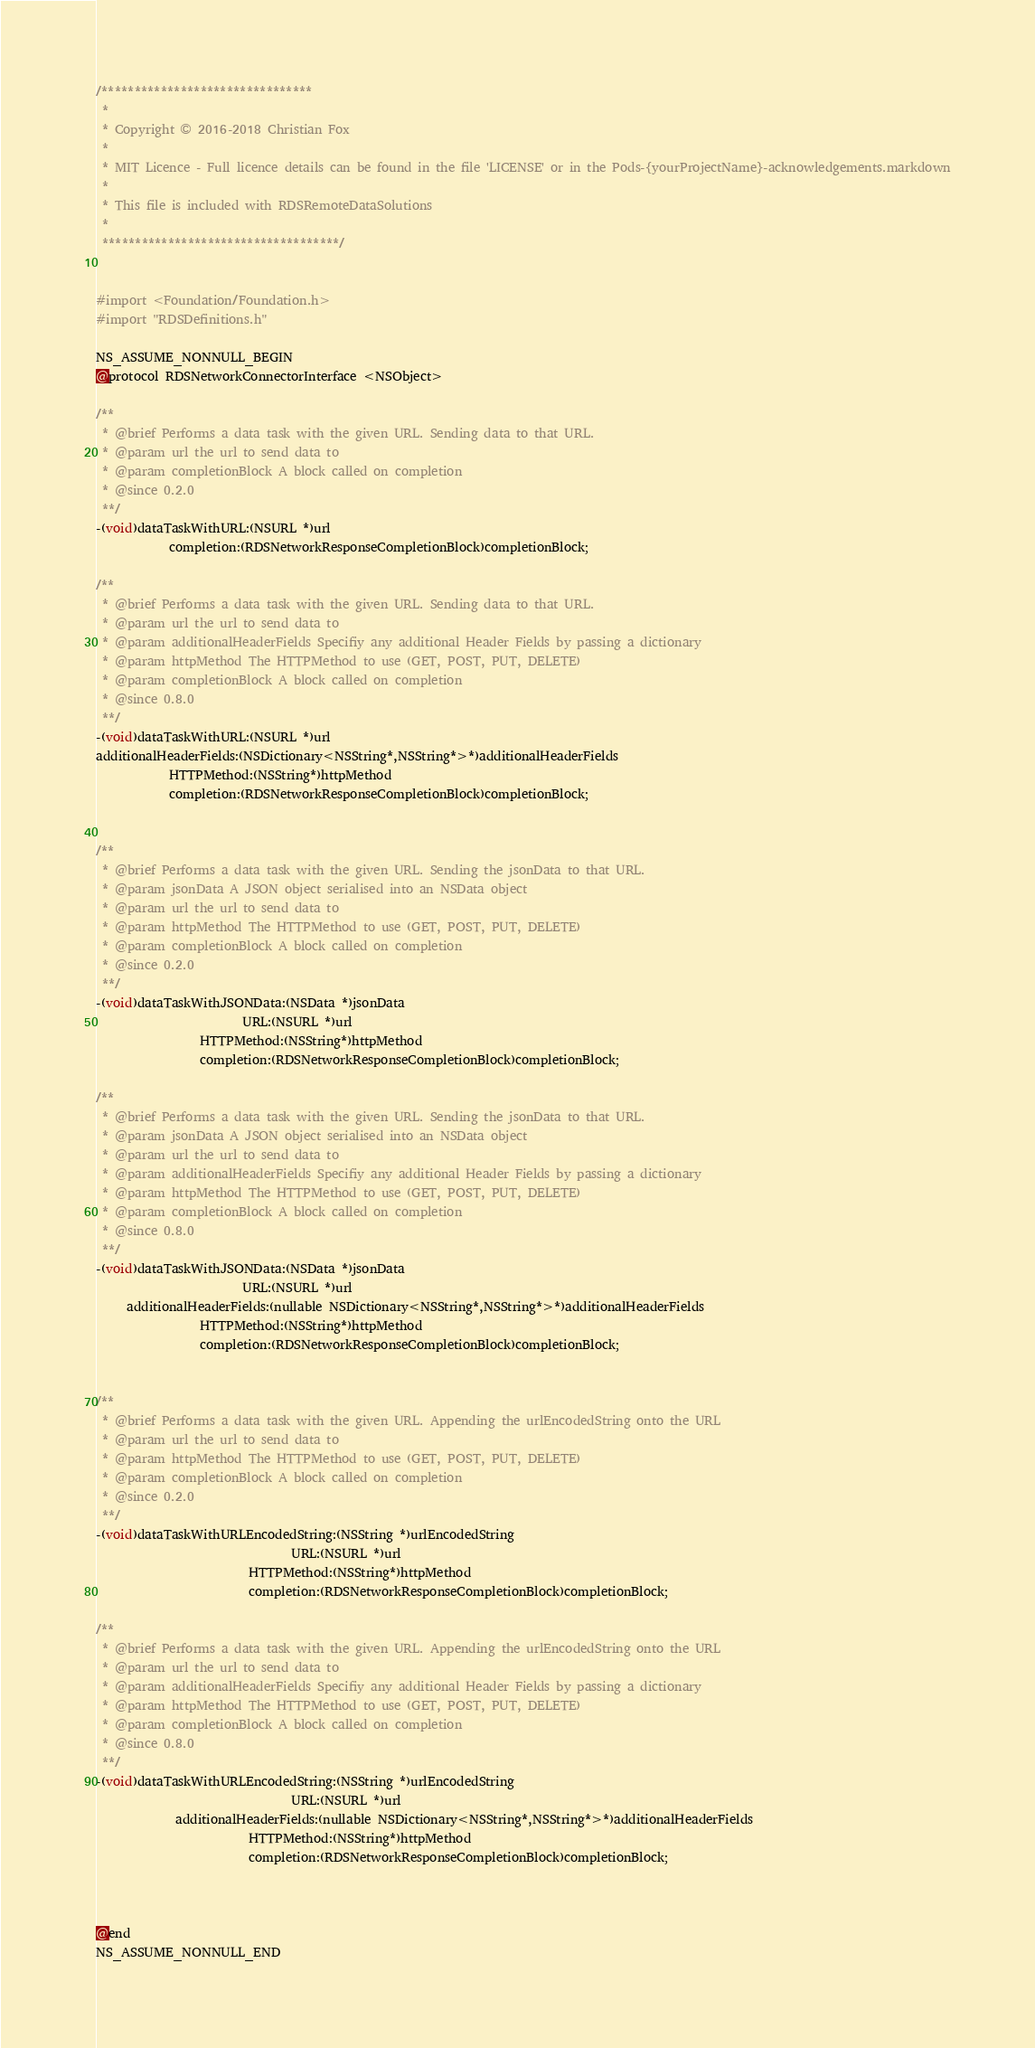Convert code to text. <code><loc_0><loc_0><loc_500><loc_500><_C_>/********************************
 *
 * Copyright © 2016-2018 Christian Fox
 *
 * MIT Licence - Full licence details can be found in the file 'LICENSE' or in the Pods-{yourProjectName}-acknowledgements.markdown
 *
 * This file is included with RDSRemoteDataSolutions
 *
 ************************************/


#import <Foundation/Foundation.h>
#import "RDSDefinitions.h"

NS_ASSUME_NONNULL_BEGIN
@protocol RDSNetworkConnectorInterface <NSObject>

/**
 * @brief Performs a data task with the given URL. Sending data to that URL.
 * @param url the url to send data to
 * @param completionBlock A block called on completion
 * @since 0.2.0
 **/
-(void)dataTaskWithURL:(NSURL *)url
            completion:(RDSNetworkResponseCompletionBlock)completionBlock;

/**
 * @brief Performs a data task with the given URL. Sending data to that URL.
 * @param url the url to send data to
 * @param additionalHeaderFields Specifiy any additional Header Fields by passing a dictionary
 * @param httpMethod The HTTPMethod to use (GET, POST, PUT, DELETE)
 * @param completionBlock A block called on completion
 * @since 0.8.0
 **/
-(void)dataTaskWithURL:(NSURL *)url
additionalHeaderFields:(NSDictionary<NSString*,NSString*>*)additionalHeaderFields
            HTTPMethod:(NSString*)httpMethod
            completion:(RDSNetworkResponseCompletionBlock)completionBlock;


/**
 * @brief Performs a data task with the given URL. Sending the jsonData to that URL.
 * @param jsonData A JSON object serialised into an NSData object
 * @param url the url to send data to
 * @param httpMethod The HTTPMethod to use (GET, POST, PUT, DELETE)
 * @param completionBlock A block called on completion
 * @since 0.2.0
 **/
-(void)dataTaskWithJSONData:(NSData *)jsonData
                        URL:(NSURL *)url
                 HTTPMethod:(NSString*)httpMethod
                 completion:(RDSNetworkResponseCompletionBlock)completionBlock;

/**
 * @brief Performs a data task with the given URL. Sending the jsonData to that URL.
 * @param jsonData A JSON object serialised into an NSData object
 * @param url the url to send data to
 * @param additionalHeaderFields Specifiy any additional Header Fields by passing a dictionary
 * @param httpMethod The HTTPMethod to use (GET, POST, PUT, DELETE)
 * @param completionBlock A block called on completion
 * @since 0.8.0
 **/
-(void)dataTaskWithJSONData:(NSData *)jsonData
                        URL:(NSURL *)url
     additionalHeaderFields:(nullable NSDictionary<NSString*,NSString*>*)additionalHeaderFields
                 HTTPMethod:(NSString*)httpMethod
                 completion:(RDSNetworkResponseCompletionBlock)completionBlock;


/**
 * @brief Performs a data task with the given URL. Appending the urlEncodedString onto the URL
 * @param url the url to send data to
 * @param httpMethod The HTTPMethod to use (GET, POST, PUT, DELETE)
 * @param completionBlock A block called on completion
 * @since 0.2.0
 **/
-(void)dataTaskWithURLEncodedString:(NSString *)urlEncodedString
                                URL:(NSURL *)url
                         HTTPMethod:(NSString*)httpMethod
                         completion:(RDSNetworkResponseCompletionBlock)completionBlock;

/**
 * @brief Performs a data task with the given URL. Appending the urlEncodedString onto the URL
 * @param url the url to send data to
 * @param additionalHeaderFields Specifiy any additional Header Fields by passing a dictionary
 * @param httpMethod The HTTPMethod to use (GET, POST, PUT, DELETE)
 * @param completionBlock A block called on completion
 * @since 0.8.0
 **/
-(void)dataTaskWithURLEncodedString:(NSString *)urlEncodedString
                                URL:(NSURL *)url
             additionalHeaderFields:(nullable NSDictionary<NSString*,NSString*>*)additionalHeaderFields
                         HTTPMethod:(NSString*)httpMethod
                         completion:(RDSNetworkResponseCompletionBlock)completionBlock;



@end
NS_ASSUME_NONNULL_END
</code> 